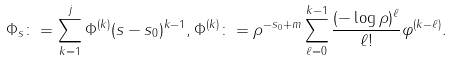<formula> <loc_0><loc_0><loc_500><loc_500>\Phi _ { s } \colon = \sum _ { k = 1 } ^ { j } \Phi ^ { ( k ) } ( s - s _ { 0 } ) ^ { k - 1 } , \Phi ^ { ( k ) } \colon = \rho ^ { - s _ { 0 } + m } \sum _ { \ell = 0 } ^ { k - 1 } \frac { ( - \log \rho ) ^ { \ell } } { \ell ! } \varphi ^ { ( k - \ell ) } .</formula> 